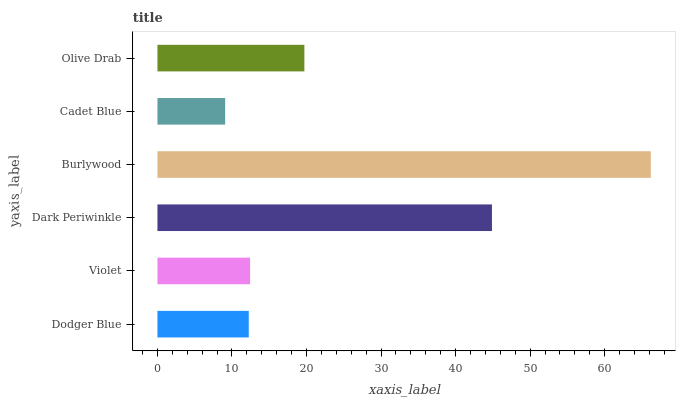Is Cadet Blue the minimum?
Answer yes or no. Yes. Is Burlywood the maximum?
Answer yes or no. Yes. Is Violet the minimum?
Answer yes or no. No. Is Violet the maximum?
Answer yes or no. No. Is Violet greater than Dodger Blue?
Answer yes or no. Yes. Is Dodger Blue less than Violet?
Answer yes or no. Yes. Is Dodger Blue greater than Violet?
Answer yes or no. No. Is Violet less than Dodger Blue?
Answer yes or no. No. Is Olive Drab the high median?
Answer yes or no. Yes. Is Violet the low median?
Answer yes or no. Yes. Is Violet the high median?
Answer yes or no. No. Is Burlywood the low median?
Answer yes or no. No. 